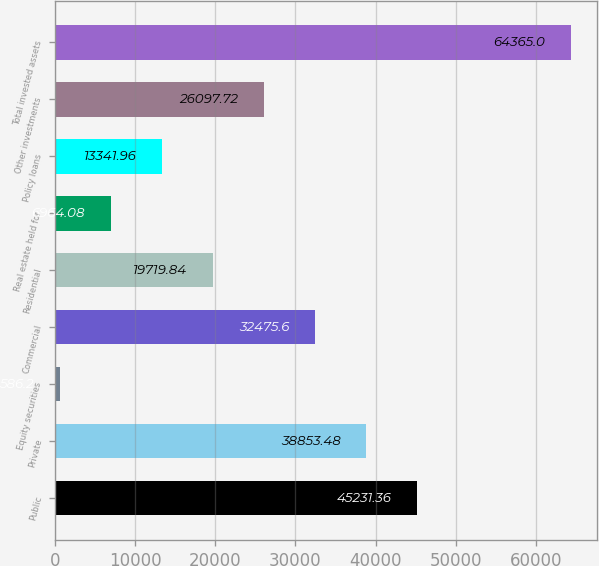Convert chart. <chart><loc_0><loc_0><loc_500><loc_500><bar_chart><fcel>Public<fcel>Private<fcel>Equity securities<fcel>Commercial<fcel>Residential<fcel>Real estate held for<fcel>Policy loans<fcel>Other investments<fcel>Total invested assets<nl><fcel>45231.4<fcel>38853.5<fcel>586.2<fcel>32475.6<fcel>19719.8<fcel>6964.08<fcel>13342<fcel>26097.7<fcel>64365<nl></chart> 